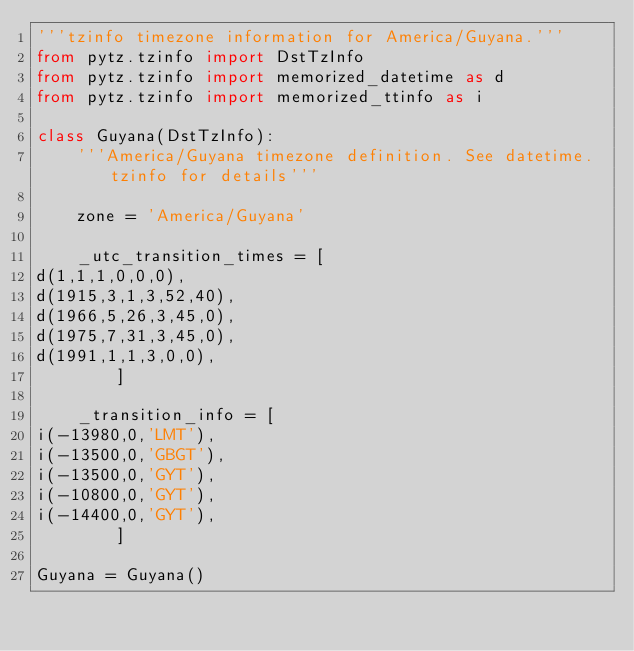<code> <loc_0><loc_0><loc_500><loc_500><_Python_>'''tzinfo timezone information for America/Guyana.'''
from pytz.tzinfo import DstTzInfo
from pytz.tzinfo import memorized_datetime as d
from pytz.tzinfo import memorized_ttinfo as i

class Guyana(DstTzInfo):
    '''America/Guyana timezone definition. See datetime.tzinfo for details'''

    zone = 'America/Guyana'

    _utc_transition_times = [
d(1,1,1,0,0,0),
d(1915,3,1,3,52,40),
d(1966,5,26,3,45,0),
d(1975,7,31,3,45,0),
d(1991,1,1,3,0,0),
        ]

    _transition_info = [
i(-13980,0,'LMT'),
i(-13500,0,'GBGT'),
i(-13500,0,'GYT'),
i(-10800,0,'GYT'),
i(-14400,0,'GYT'),
        ]

Guyana = Guyana()

</code> 